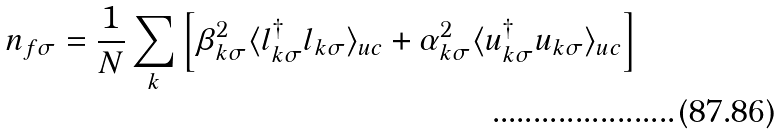<formula> <loc_0><loc_0><loc_500><loc_500>n _ { f \sigma } = \frac { 1 } { N } \sum _ { k } \left [ \beta _ { k \sigma } ^ { 2 } \langle l _ { k \sigma } ^ { \dagger } l _ { k \sigma } \rangle _ { u c } + \alpha _ { k \sigma } ^ { 2 } \langle u _ { k \sigma } ^ { \dagger } u _ { k \sigma } \rangle _ { u c } \right ]</formula> 